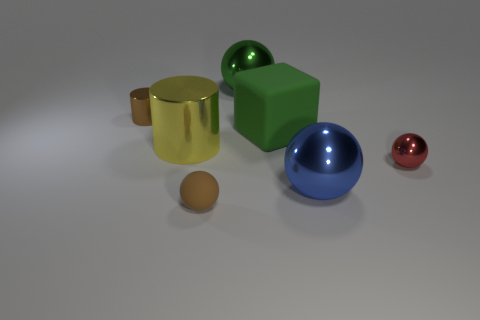Subtract 1 balls. How many balls are left? 3 Add 1 big cyan matte blocks. How many objects exist? 8 Subtract all blocks. How many objects are left? 6 Subtract all yellow metallic objects. Subtract all large purple balls. How many objects are left? 6 Add 3 large cylinders. How many large cylinders are left? 4 Add 7 purple rubber cubes. How many purple rubber cubes exist? 7 Subtract 1 brown balls. How many objects are left? 6 